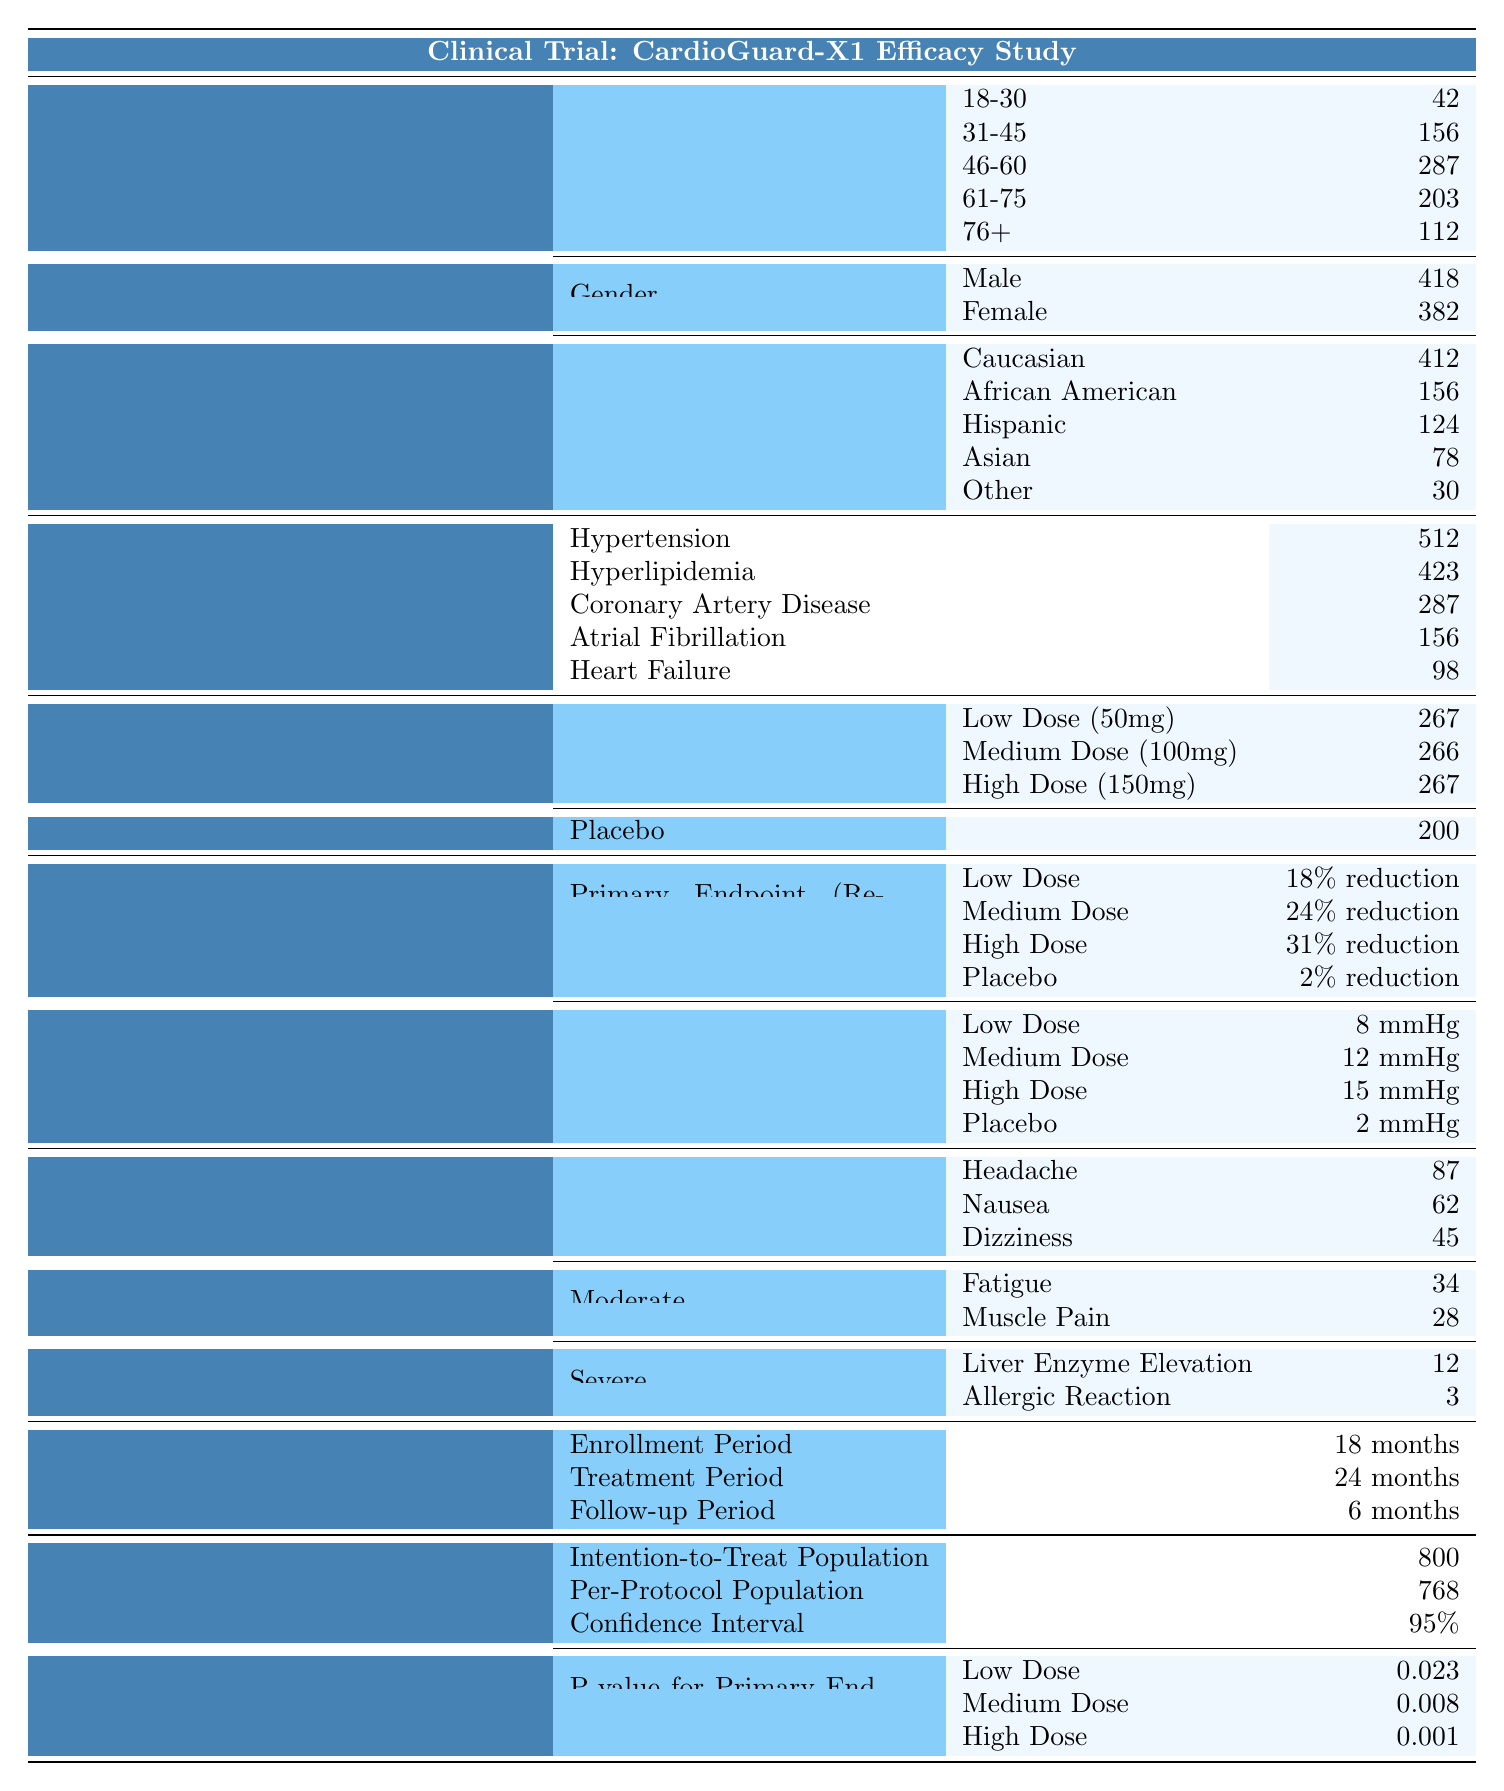What is the total number of patients in the clinical trial? To find the total number of patients, sum up the numbers from each treatment group: 267 (Low Dose) + 266 (Medium Dose) + 267 (High Dose) + 200 (Placebo) = 1000 patients.
Answer: 1000 How many patients fall within the age group of 46-60? Referring to the "Age Groups" section, the number of patients aged 46-60 is directly listed as 287.
Answer: 287 What percentage of patients experienced severe adverse events? To calculate the percentage of patients who experienced severe adverse events: total severe events = 12 (Liver Enzyme Elevation) + 3 (Allergic Reaction) = 15. The total number of patients is 1000. Thus, the percentage is (15/1000) * 100 = 1.5%.
Answer: 1.5% Which treatment group had the highest reduction in major adverse cardiovascular events? Looking at the "Primary Endpoint" section, the High Dose of CardioGuard-X1 reported the highest reduction at 31%.
Answer: High Dose (150mg) of CardioGuard-X1 How many patients were assigned to each dose of CardioGuard-X1? The table shows 267 patients for Low Dose, 266 for Medium Dose, and 267 for High Dose, summing to a total of 800 patients assigned to CardioGuard-X1.
Answer: 800 What is the difference in LDL cholesterol reduction between the high dose and placebo? According to the "LDL Cholesterol Reduction" section, the High Dose of CardioGuard-X1 has a reduction of 28%, while Placebo has a reduction of 3%. The difference is 28% - 3% = 25%.
Answer: 25% Is the reduction in blood pressure higher for the medium dose of CardioGuard-X1 than for the placebo treatment? The medium dose of CardioGuard-X1 has a blood pressure reduction of 12 mmHg, while the placebo has a reduction of 2 mmHg. Since 12 mmHg is greater than 2 mmHg, the statement is true.
Answer: Yes What is the ratio of adverse events classified as mild compared to severe? From the table, the number of mild adverse events is 87 (Headache) + 62 (Nausea) + 45 (Dizziness) = 194. The severe events total 12 (Liver Enzyme Elevation) + 3 (Allergic Reaction) = 15. The ratio is 194:15.
Answer: 194:15 Was there a significant statistical difference in the primary endpoint between any dose of CardioGuard-X1 and placebo? The P-values for the primary endpoint are 0.023 for Low Dose, 0.008 for Medium Dose, and 0.001 for High Dose. All are less than 0.05, indicating significant differences compared to the placebo (which has no listed P-value for comparison).
Answer: Yes How many more patients in the hypertension category than heart failure? For the baseline cardiovascular conditions, there are 512 patients with hypertension and 98 with heart failure. The difference is 512 - 98 = 414.
Answer: 414 What is the average age of patients in the 31-45 age group and the 61-75 age group combined? The number of patients in the 31-45 age group is 156, and in the 61-75 age group, it is 203. The average number is (156 + 203) / 2 = 179.5, but since we need whole numbers, we consider just the sum.
Answer: 179.5 